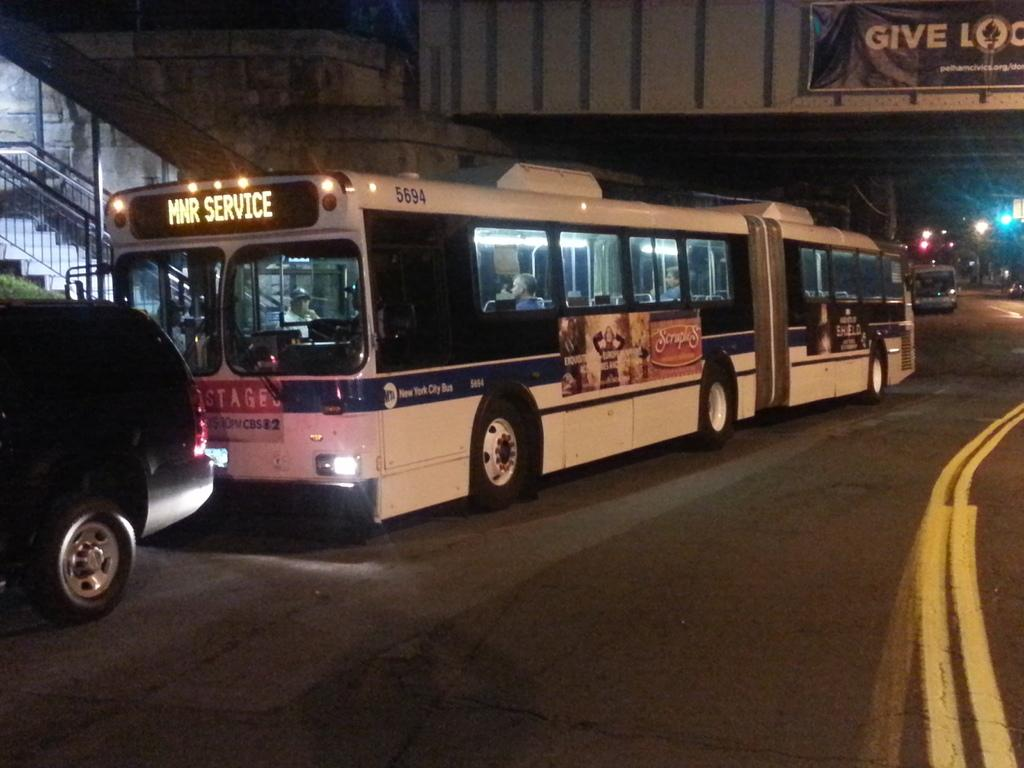What can be seen on the road in the image? There are vehicles on the road in the image. What type of natural elements are present in the image? There are plants in the image. What architectural feature is visible in the image? There are stairs in the image. What might be used to hold onto the stairs? There are staircase holders in the image. What can provide illumination in the image? There are lights in the image. What can be read or deciphered in the image? There is some text in the image. What is attached to a board in the image? There are objects on a board in the image. What other objects can be seen in the image? There are other objects in the image. How does the comfort level of the stitch in the image affect the quarter? There is no stitch or quarter present in the image, so this question cannot be answered. 